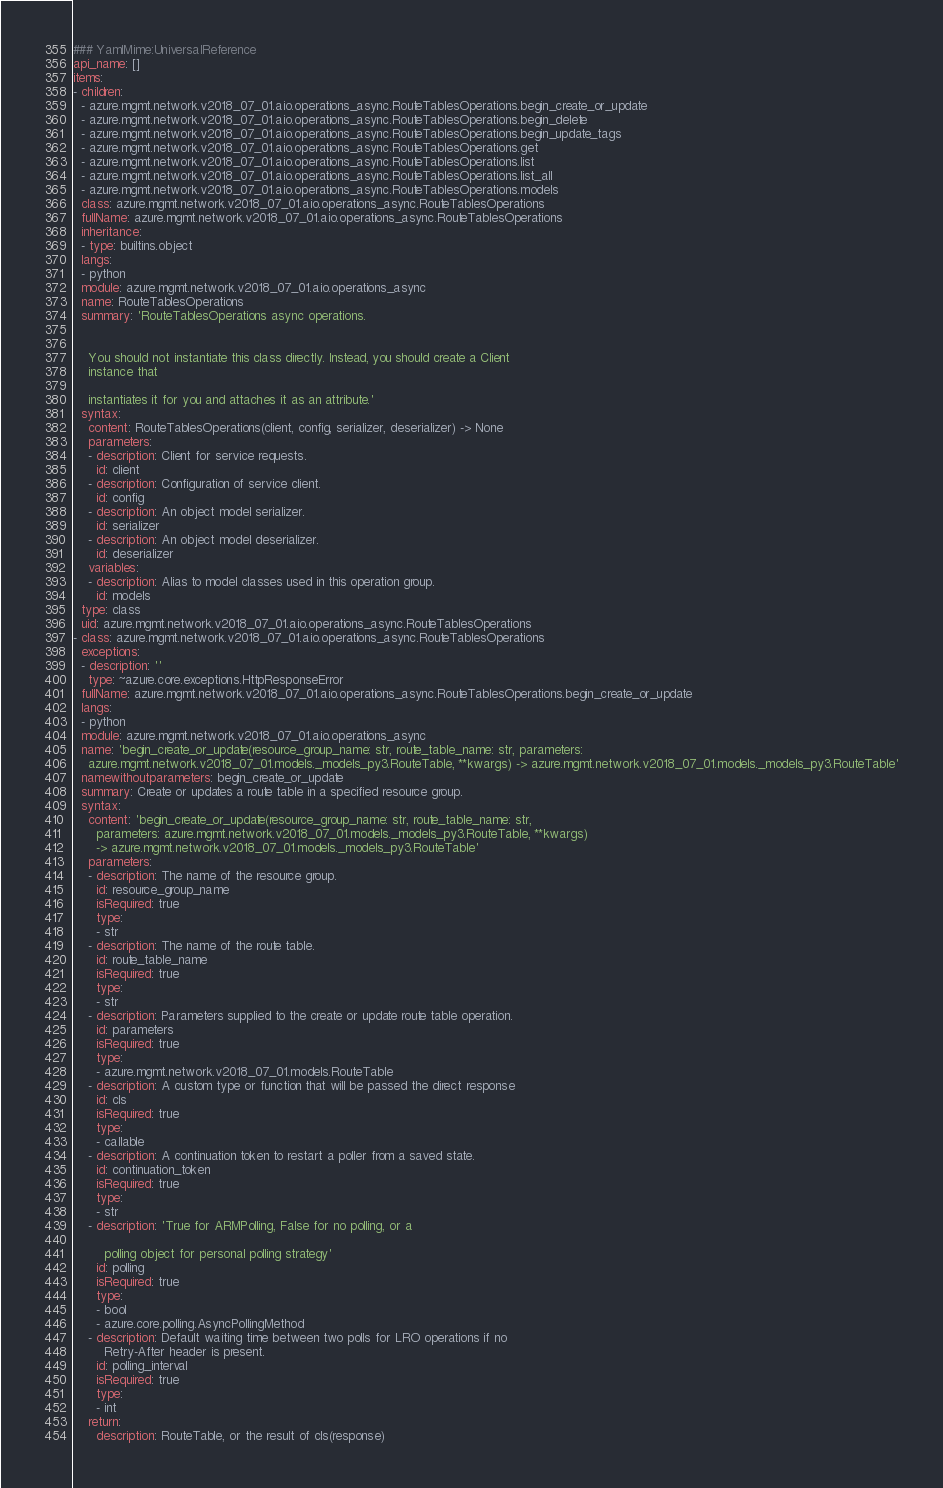Convert code to text. <code><loc_0><loc_0><loc_500><loc_500><_YAML_>### YamlMime:UniversalReference
api_name: []
items:
- children:
  - azure.mgmt.network.v2018_07_01.aio.operations_async.RouteTablesOperations.begin_create_or_update
  - azure.mgmt.network.v2018_07_01.aio.operations_async.RouteTablesOperations.begin_delete
  - azure.mgmt.network.v2018_07_01.aio.operations_async.RouteTablesOperations.begin_update_tags
  - azure.mgmt.network.v2018_07_01.aio.operations_async.RouteTablesOperations.get
  - azure.mgmt.network.v2018_07_01.aio.operations_async.RouteTablesOperations.list
  - azure.mgmt.network.v2018_07_01.aio.operations_async.RouteTablesOperations.list_all
  - azure.mgmt.network.v2018_07_01.aio.operations_async.RouteTablesOperations.models
  class: azure.mgmt.network.v2018_07_01.aio.operations_async.RouteTablesOperations
  fullName: azure.mgmt.network.v2018_07_01.aio.operations_async.RouteTablesOperations
  inheritance:
  - type: builtins.object
  langs:
  - python
  module: azure.mgmt.network.v2018_07_01.aio.operations_async
  name: RouteTablesOperations
  summary: 'RouteTablesOperations async operations.


    You should not instantiate this class directly. Instead, you should create a Client
    instance that

    instantiates it for you and attaches it as an attribute.'
  syntax:
    content: RouteTablesOperations(client, config, serializer, deserializer) -> None
    parameters:
    - description: Client for service requests.
      id: client
    - description: Configuration of service client.
      id: config
    - description: An object model serializer.
      id: serializer
    - description: An object model deserializer.
      id: deserializer
    variables:
    - description: Alias to model classes used in this operation group.
      id: models
  type: class
  uid: azure.mgmt.network.v2018_07_01.aio.operations_async.RouteTablesOperations
- class: azure.mgmt.network.v2018_07_01.aio.operations_async.RouteTablesOperations
  exceptions:
  - description: ''
    type: ~azure.core.exceptions.HttpResponseError
  fullName: azure.mgmt.network.v2018_07_01.aio.operations_async.RouteTablesOperations.begin_create_or_update
  langs:
  - python
  module: azure.mgmt.network.v2018_07_01.aio.operations_async
  name: 'begin_create_or_update(resource_group_name: str, route_table_name: str, parameters:
    azure.mgmt.network.v2018_07_01.models._models_py3.RouteTable, **kwargs) -> azure.mgmt.network.v2018_07_01.models._models_py3.RouteTable'
  namewithoutparameters: begin_create_or_update
  summary: Create or updates a route table in a specified resource group.
  syntax:
    content: 'begin_create_or_update(resource_group_name: str, route_table_name: str,
      parameters: azure.mgmt.network.v2018_07_01.models._models_py3.RouteTable, **kwargs)
      -> azure.mgmt.network.v2018_07_01.models._models_py3.RouteTable'
    parameters:
    - description: The name of the resource group.
      id: resource_group_name
      isRequired: true
      type:
      - str
    - description: The name of the route table.
      id: route_table_name
      isRequired: true
      type:
      - str
    - description: Parameters supplied to the create or update route table operation.
      id: parameters
      isRequired: true
      type:
      - azure.mgmt.network.v2018_07_01.models.RouteTable
    - description: A custom type or function that will be passed the direct response
      id: cls
      isRequired: true
      type:
      - callable
    - description: A continuation token to restart a poller from a saved state.
      id: continuation_token
      isRequired: true
      type:
      - str
    - description: 'True for ARMPolling, False for no polling, or a

        polling object for personal polling strategy'
      id: polling
      isRequired: true
      type:
      - bool
      - azure.core.polling.AsyncPollingMethod
    - description: Default waiting time between two polls for LRO operations if no
        Retry-After header is present.
      id: polling_interval
      isRequired: true
      type:
      - int
    return:
      description: RouteTable, or the result of cls(response)</code> 